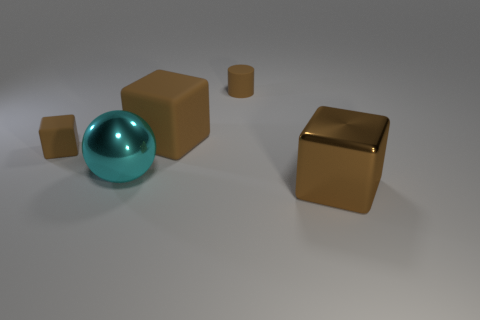What is the size of the metal block that is the same color as the small rubber cylinder?
Keep it short and to the point. Large. Is there anything else that is the same shape as the cyan shiny object?
Give a very brief answer. No. There is a shiny cube that is the same size as the cyan ball; what is its color?
Ensure brevity in your answer.  Brown. Is the size of the cyan shiny thing the same as the brown cylinder?
Provide a succinct answer. No. There is a brown cube that is on the right side of the tiny matte cube and on the left side of the metal block; what size is it?
Ensure brevity in your answer.  Large. How many matte things are either cyan balls or blue cubes?
Your response must be concise. 0. Is the number of tiny rubber cylinders behind the cyan sphere greater than the number of blue spheres?
Offer a terse response. Yes. There is a big brown object that is behind the big shiny cube; what is it made of?
Offer a terse response. Rubber. How many cyan things have the same material as the cyan ball?
Your answer should be very brief. 0. There is a large object that is both on the right side of the big metal sphere and behind the big metal block; what shape is it?
Make the answer very short. Cube. 